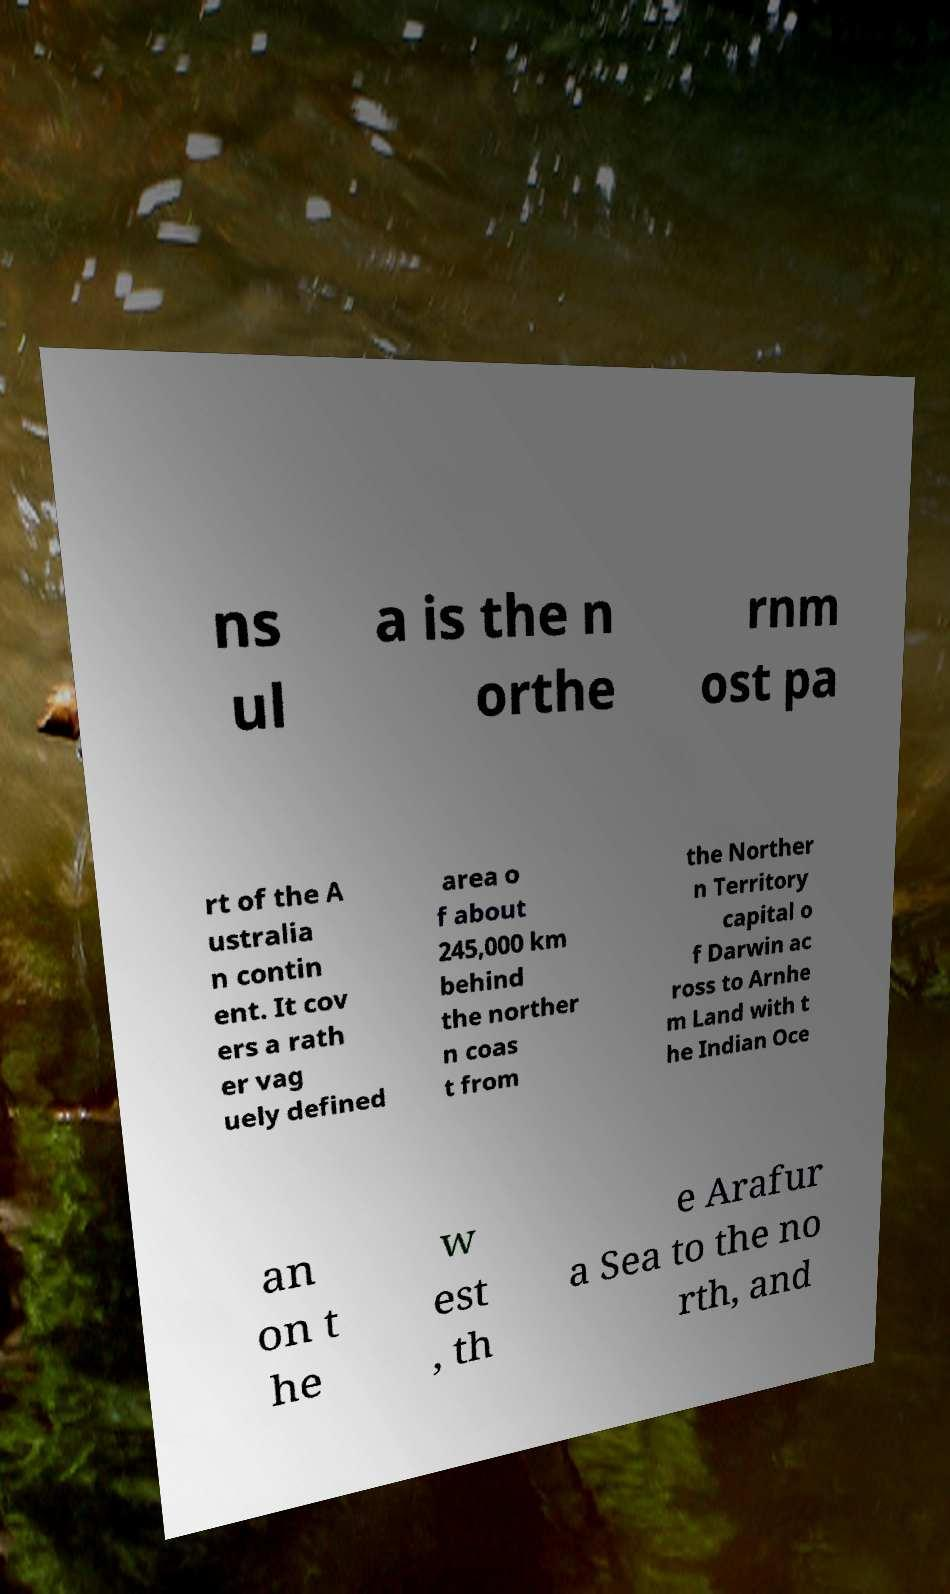For documentation purposes, I need the text within this image transcribed. Could you provide that? ns ul a is the n orthe rnm ost pa rt of the A ustralia n contin ent. It cov ers a rath er vag uely defined area o f about 245,000 km behind the norther n coas t from the Norther n Territory capital o f Darwin ac ross to Arnhe m Land with t he Indian Oce an on t he w est , th e Arafur a Sea to the no rth, and 